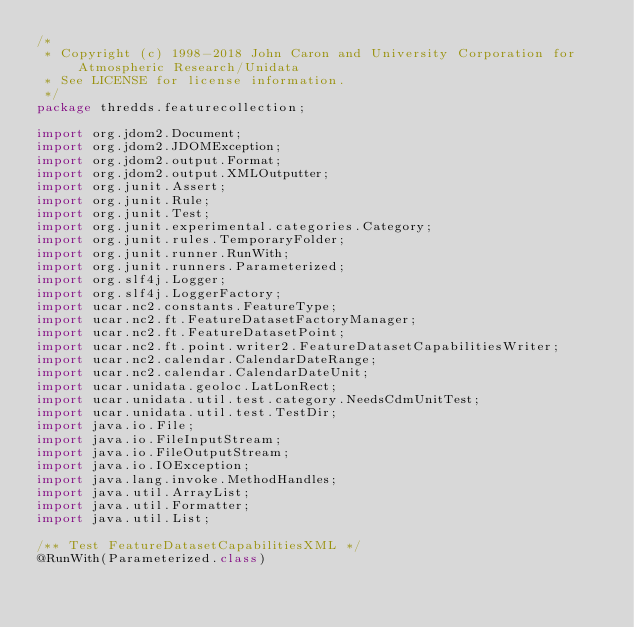<code> <loc_0><loc_0><loc_500><loc_500><_Java_>/*
 * Copyright (c) 1998-2018 John Caron and University Corporation for Atmospheric Research/Unidata
 * See LICENSE for license information.
 */
package thredds.featurecollection;

import org.jdom2.Document;
import org.jdom2.JDOMException;
import org.jdom2.output.Format;
import org.jdom2.output.XMLOutputter;
import org.junit.Assert;
import org.junit.Rule;
import org.junit.Test;
import org.junit.experimental.categories.Category;
import org.junit.rules.TemporaryFolder;
import org.junit.runner.RunWith;
import org.junit.runners.Parameterized;
import org.slf4j.Logger;
import org.slf4j.LoggerFactory;
import ucar.nc2.constants.FeatureType;
import ucar.nc2.ft.FeatureDatasetFactoryManager;
import ucar.nc2.ft.FeatureDatasetPoint;
import ucar.nc2.ft.point.writer2.FeatureDatasetCapabilitiesWriter;
import ucar.nc2.calendar.CalendarDateRange;
import ucar.nc2.calendar.CalendarDateUnit;
import ucar.unidata.geoloc.LatLonRect;
import ucar.unidata.util.test.category.NeedsCdmUnitTest;
import ucar.unidata.util.test.TestDir;
import java.io.File;
import java.io.FileInputStream;
import java.io.FileOutputStream;
import java.io.IOException;
import java.lang.invoke.MethodHandles;
import java.util.ArrayList;
import java.util.Formatter;
import java.util.List;

/** Test FeatureDatasetCapabilitiesXML */
@RunWith(Parameterized.class)</code> 